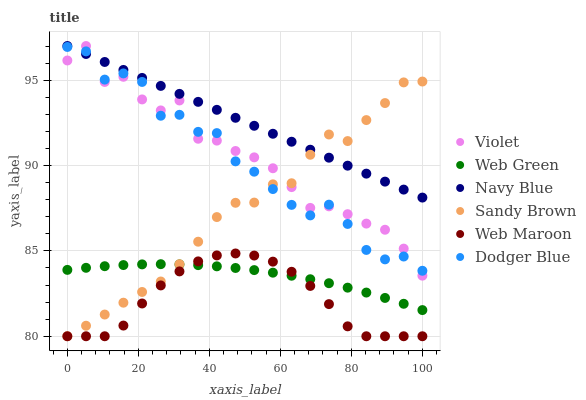Does Web Maroon have the minimum area under the curve?
Answer yes or no. Yes. Does Navy Blue have the maximum area under the curve?
Answer yes or no. Yes. Does Web Green have the minimum area under the curve?
Answer yes or no. No. Does Web Green have the maximum area under the curve?
Answer yes or no. No. Is Navy Blue the smoothest?
Answer yes or no. Yes. Is Dodger Blue the roughest?
Answer yes or no. Yes. Is Web Maroon the smoothest?
Answer yes or no. No. Is Web Maroon the roughest?
Answer yes or no. No. Does Web Maroon have the lowest value?
Answer yes or no. Yes. Does Web Green have the lowest value?
Answer yes or no. No. Does Violet have the highest value?
Answer yes or no. Yes. Does Web Maroon have the highest value?
Answer yes or no. No. Is Web Maroon less than Dodger Blue?
Answer yes or no. Yes. Is Dodger Blue greater than Web Green?
Answer yes or no. Yes. Does Web Maroon intersect Sandy Brown?
Answer yes or no. Yes. Is Web Maroon less than Sandy Brown?
Answer yes or no. No. Is Web Maroon greater than Sandy Brown?
Answer yes or no. No. Does Web Maroon intersect Dodger Blue?
Answer yes or no. No. 